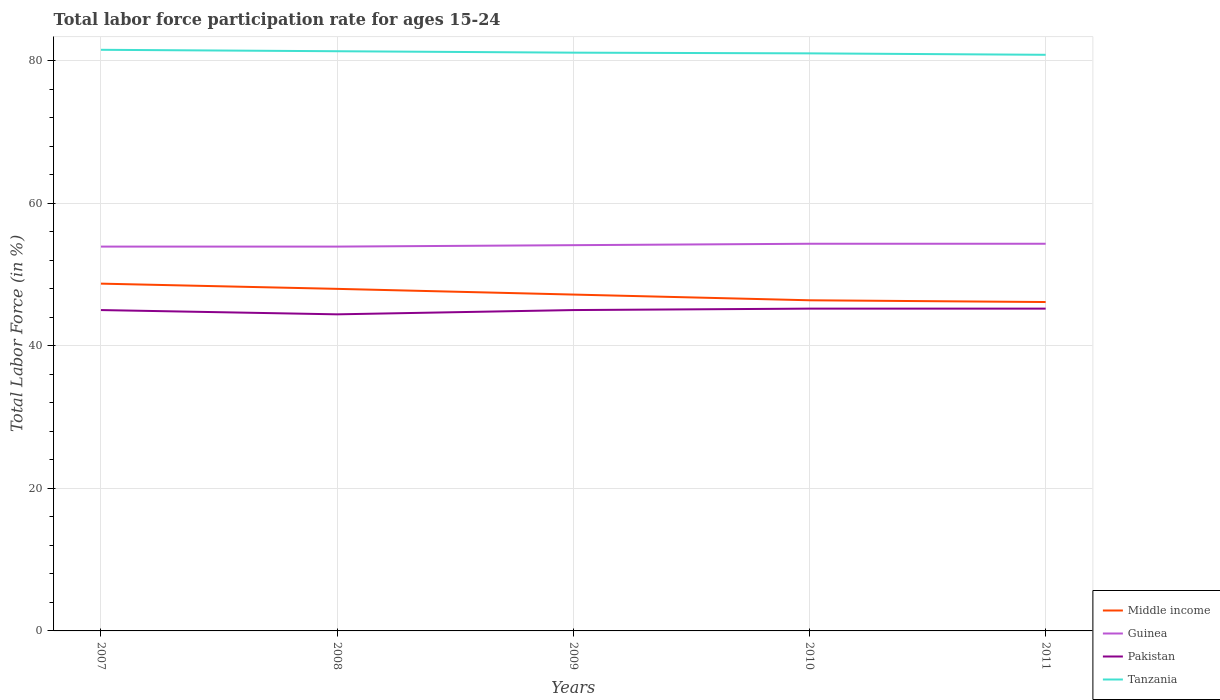How many different coloured lines are there?
Your answer should be compact. 4. Does the line corresponding to Guinea intersect with the line corresponding to Middle income?
Keep it short and to the point. No. Across all years, what is the maximum labor force participation rate in Guinea?
Give a very brief answer. 53.9. What is the difference between the highest and the second highest labor force participation rate in Guinea?
Offer a very short reply. 0.4. Is the labor force participation rate in Middle income strictly greater than the labor force participation rate in Tanzania over the years?
Your answer should be compact. Yes. How many years are there in the graph?
Keep it short and to the point. 5. What is the difference between two consecutive major ticks on the Y-axis?
Your answer should be very brief. 20. Does the graph contain grids?
Keep it short and to the point. Yes. Where does the legend appear in the graph?
Your response must be concise. Bottom right. What is the title of the graph?
Keep it short and to the point. Total labor force participation rate for ages 15-24. Does "Bosnia and Herzegovina" appear as one of the legend labels in the graph?
Make the answer very short. No. What is the Total Labor Force (in %) in Middle income in 2007?
Offer a very short reply. 48.7. What is the Total Labor Force (in %) in Guinea in 2007?
Make the answer very short. 53.9. What is the Total Labor Force (in %) in Tanzania in 2007?
Your answer should be very brief. 81.5. What is the Total Labor Force (in %) in Middle income in 2008?
Offer a very short reply. 47.97. What is the Total Labor Force (in %) in Guinea in 2008?
Give a very brief answer. 53.9. What is the Total Labor Force (in %) in Pakistan in 2008?
Offer a very short reply. 44.4. What is the Total Labor Force (in %) in Tanzania in 2008?
Offer a very short reply. 81.3. What is the Total Labor Force (in %) in Middle income in 2009?
Give a very brief answer. 47.17. What is the Total Labor Force (in %) of Guinea in 2009?
Keep it short and to the point. 54.1. What is the Total Labor Force (in %) in Pakistan in 2009?
Your answer should be very brief. 45. What is the Total Labor Force (in %) in Tanzania in 2009?
Offer a very short reply. 81.1. What is the Total Labor Force (in %) of Middle income in 2010?
Ensure brevity in your answer.  46.37. What is the Total Labor Force (in %) in Guinea in 2010?
Ensure brevity in your answer.  54.3. What is the Total Labor Force (in %) in Pakistan in 2010?
Provide a succinct answer. 45.2. What is the Total Labor Force (in %) in Tanzania in 2010?
Ensure brevity in your answer.  81. What is the Total Labor Force (in %) in Middle income in 2011?
Your response must be concise. 46.13. What is the Total Labor Force (in %) in Guinea in 2011?
Offer a terse response. 54.3. What is the Total Labor Force (in %) in Pakistan in 2011?
Your response must be concise. 45.2. What is the Total Labor Force (in %) of Tanzania in 2011?
Your answer should be very brief. 80.8. Across all years, what is the maximum Total Labor Force (in %) in Middle income?
Your response must be concise. 48.7. Across all years, what is the maximum Total Labor Force (in %) in Guinea?
Offer a very short reply. 54.3. Across all years, what is the maximum Total Labor Force (in %) in Pakistan?
Keep it short and to the point. 45.2. Across all years, what is the maximum Total Labor Force (in %) of Tanzania?
Provide a short and direct response. 81.5. Across all years, what is the minimum Total Labor Force (in %) of Middle income?
Offer a very short reply. 46.13. Across all years, what is the minimum Total Labor Force (in %) of Guinea?
Ensure brevity in your answer.  53.9. Across all years, what is the minimum Total Labor Force (in %) of Pakistan?
Offer a very short reply. 44.4. Across all years, what is the minimum Total Labor Force (in %) in Tanzania?
Your answer should be very brief. 80.8. What is the total Total Labor Force (in %) of Middle income in the graph?
Offer a very short reply. 236.35. What is the total Total Labor Force (in %) in Guinea in the graph?
Your answer should be very brief. 270.5. What is the total Total Labor Force (in %) of Pakistan in the graph?
Your answer should be very brief. 224.8. What is the total Total Labor Force (in %) of Tanzania in the graph?
Ensure brevity in your answer.  405.7. What is the difference between the Total Labor Force (in %) in Middle income in 2007 and that in 2008?
Your answer should be very brief. 0.73. What is the difference between the Total Labor Force (in %) in Guinea in 2007 and that in 2008?
Your response must be concise. 0. What is the difference between the Total Labor Force (in %) in Middle income in 2007 and that in 2009?
Give a very brief answer. 1.53. What is the difference between the Total Labor Force (in %) of Guinea in 2007 and that in 2009?
Provide a succinct answer. -0.2. What is the difference between the Total Labor Force (in %) in Tanzania in 2007 and that in 2009?
Make the answer very short. 0.4. What is the difference between the Total Labor Force (in %) of Middle income in 2007 and that in 2010?
Give a very brief answer. 2.33. What is the difference between the Total Labor Force (in %) of Pakistan in 2007 and that in 2010?
Ensure brevity in your answer.  -0.2. What is the difference between the Total Labor Force (in %) of Middle income in 2007 and that in 2011?
Keep it short and to the point. 2.58. What is the difference between the Total Labor Force (in %) in Guinea in 2007 and that in 2011?
Make the answer very short. -0.4. What is the difference between the Total Labor Force (in %) of Pakistan in 2007 and that in 2011?
Give a very brief answer. -0.2. What is the difference between the Total Labor Force (in %) in Middle income in 2008 and that in 2009?
Provide a succinct answer. 0.8. What is the difference between the Total Labor Force (in %) in Guinea in 2008 and that in 2009?
Provide a short and direct response. -0.2. What is the difference between the Total Labor Force (in %) of Middle income in 2008 and that in 2010?
Your answer should be very brief. 1.6. What is the difference between the Total Labor Force (in %) of Pakistan in 2008 and that in 2010?
Ensure brevity in your answer.  -0.8. What is the difference between the Total Labor Force (in %) in Middle income in 2008 and that in 2011?
Give a very brief answer. 1.85. What is the difference between the Total Labor Force (in %) in Guinea in 2008 and that in 2011?
Your answer should be compact. -0.4. What is the difference between the Total Labor Force (in %) of Middle income in 2009 and that in 2010?
Your answer should be very brief. 0.8. What is the difference between the Total Labor Force (in %) in Guinea in 2009 and that in 2010?
Provide a succinct answer. -0.2. What is the difference between the Total Labor Force (in %) of Middle income in 2009 and that in 2011?
Keep it short and to the point. 1.05. What is the difference between the Total Labor Force (in %) of Guinea in 2009 and that in 2011?
Keep it short and to the point. -0.2. What is the difference between the Total Labor Force (in %) of Middle income in 2010 and that in 2011?
Offer a terse response. 0.25. What is the difference between the Total Labor Force (in %) of Tanzania in 2010 and that in 2011?
Provide a succinct answer. 0.2. What is the difference between the Total Labor Force (in %) in Middle income in 2007 and the Total Labor Force (in %) in Guinea in 2008?
Your response must be concise. -5.2. What is the difference between the Total Labor Force (in %) in Middle income in 2007 and the Total Labor Force (in %) in Pakistan in 2008?
Offer a terse response. 4.3. What is the difference between the Total Labor Force (in %) of Middle income in 2007 and the Total Labor Force (in %) of Tanzania in 2008?
Your answer should be very brief. -32.6. What is the difference between the Total Labor Force (in %) in Guinea in 2007 and the Total Labor Force (in %) in Pakistan in 2008?
Your response must be concise. 9.5. What is the difference between the Total Labor Force (in %) of Guinea in 2007 and the Total Labor Force (in %) of Tanzania in 2008?
Your answer should be compact. -27.4. What is the difference between the Total Labor Force (in %) of Pakistan in 2007 and the Total Labor Force (in %) of Tanzania in 2008?
Give a very brief answer. -36.3. What is the difference between the Total Labor Force (in %) in Middle income in 2007 and the Total Labor Force (in %) in Guinea in 2009?
Ensure brevity in your answer.  -5.4. What is the difference between the Total Labor Force (in %) in Middle income in 2007 and the Total Labor Force (in %) in Pakistan in 2009?
Offer a terse response. 3.7. What is the difference between the Total Labor Force (in %) of Middle income in 2007 and the Total Labor Force (in %) of Tanzania in 2009?
Your response must be concise. -32.4. What is the difference between the Total Labor Force (in %) in Guinea in 2007 and the Total Labor Force (in %) in Tanzania in 2009?
Provide a short and direct response. -27.2. What is the difference between the Total Labor Force (in %) of Pakistan in 2007 and the Total Labor Force (in %) of Tanzania in 2009?
Offer a very short reply. -36.1. What is the difference between the Total Labor Force (in %) in Middle income in 2007 and the Total Labor Force (in %) in Guinea in 2010?
Your answer should be compact. -5.6. What is the difference between the Total Labor Force (in %) of Middle income in 2007 and the Total Labor Force (in %) of Pakistan in 2010?
Offer a very short reply. 3.5. What is the difference between the Total Labor Force (in %) of Middle income in 2007 and the Total Labor Force (in %) of Tanzania in 2010?
Provide a short and direct response. -32.3. What is the difference between the Total Labor Force (in %) in Guinea in 2007 and the Total Labor Force (in %) in Tanzania in 2010?
Keep it short and to the point. -27.1. What is the difference between the Total Labor Force (in %) of Pakistan in 2007 and the Total Labor Force (in %) of Tanzania in 2010?
Provide a succinct answer. -36. What is the difference between the Total Labor Force (in %) of Middle income in 2007 and the Total Labor Force (in %) of Guinea in 2011?
Offer a very short reply. -5.6. What is the difference between the Total Labor Force (in %) of Middle income in 2007 and the Total Labor Force (in %) of Pakistan in 2011?
Offer a terse response. 3.5. What is the difference between the Total Labor Force (in %) in Middle income in 2007 and the Total Labor Force (in %) in Tanzania in 2011?
Make the answer very short. -32.1. What is the difference between the Total Labor Force (in %) in Guinea in 2007 and the Total Labor Force (in %) in Tanzania in 2011?
Provide a succinct answer. -26.9. What is the difference between the Total Labor Force (in %) in Pakistan in 2007 and the Total Labor Force (in %) in Tanzania in 2011?
Offer a very short reply. -35.8. What is the difference between the Total Labor Force (in %) in Middle income in 2008 and the Total Labor Force (in %) in Guinea in 2009?
Keep it short and to the point. -6.13. What is the difference between the Total Labor Force (in %) in Middle income in 2008 and the Total Labor Force (in %) in Pakistan in 2009?
Offer a terse response. 2.97. What is the difference between the Total Labor Force (in %) in Middle income in 2008 and the Total Labor Force (in %) in Tanzania in 2009?
Your response must be concise. -33.13. What is the difference between the Total Labor Force (in %) in Guinea in 2008 and the Total Labor Force (in %) in Tanzania in 2009?
Keep it short and to the point. -27.2. What is the difference between the Total Labor Force (in %) of Pakistan in 2008 and the Total Labor Force (in %) of Tanzania in 2009?
Provide a succinct answer. -36.7. What is the difference between the Total Labor Force (in %) in Middle income in 2008 and the Total Labor Force (in %) in Guinea in 2010?
Provide a short and direct response. -6.33. What is the difference between the Total Labor Force (in %) in Middle income in 2008 and the Total Labor Force (in %) in Pakistan in 2010?
Provide a short and direct response. 2.77. What is the difference between the Total Labor Force (in %) in Middle income in 2008 and the Total Labor Force (in %) in Tanzania in 2010?
Provide a succinct answer. -33.03. What is the difference between the Total Labor Force (in %) in Guinea in 2008 and the Total Labor Force (in %) in Pakistan in 2010?
Make the answer very short. 8.7. What is the difference between the Total Labor Force (in %) in Guinea in 2008 and the Total Labor Force (in %) in Tanzania in 2010?
Ensure brevity in your answer.  -27.1. What is the difference between the Total Labor Force (in %) of Pakistan in 2008 and the Total Labor Force (in %) of Tanzania in 2010?
Keep it short and to the point. -36.6. What is the difference between the Total Labor Force (in %) of Middle income in 2008 and the Total Labor Force (in %) of Guinea in 2011?
Offer a very short reply. -6.33. What is the difference between the Total Labor Force (in %) in Middle income in 2008 and the Total Labor Force (in %) in Pakistan in 2011?
Your response must be concise. 2.77. What is the difference between the Total Labor Force (in %) in Middle income in 2008 and the Total Labor Force (in %) in Tanzania in 2011?
Offer a very short reply. -32.83. What is the difference between the Total Labor Force (in %) of Guinea in 2008 and the Total Labor Force (in %) of Tanzania in 2011?
Offer a very short reply. -26.9. What is the difference between the Total Labor Force (in %) in Pakistan in 2008 and the Total Labor Force (in %) in Tanzania in 2011?
Give a very brief answer. -36.4. What is the difference between the Total Labor Force (in %) in Middle income in 2009 and the Total Labor Force (in %) in Guinea in 2010?
Your answer should be compact. -7.13. What is the difference between the Total Labor Force (in %) of Middle income in 2009 and the Total Labor Force (in %) of Pakistan in 2010?
Provide a short and direct response. 1.97. What is the difference between the Total Labor Force (in %) of Middle income in 2009 and the Total Labor Force (in %) of Tanzania in 2010?
Ensure brevity in your answer.  -33.83. What is the difference between the Total Labor Force (in %) in Guinea in 2009 and the Total Labor Force (in %) in Tanzania in 2010?
Give a very brief answer. -26.9. What is the difference between the Total Labor Force (in %) of Pakistan in 2009 and the Total Labor Force (in %) of Tanzania in 2010?
Keep it short and to the point. -36. What is the difference between the Total Labor Force (in %) in Middle income in 2009 and the Total Labor Force (in %) in Guinea in 2011?
Your answer should be very brief. -7.13. What is the difference between the Total Labor Force (in %) in Middle income in 2009 and the Total Labor Force (in %) in Pakistan in 2011?
Provide a short and direct response. 1.97. What is the difference between the Total Labor Force (in %) of Middle income in 2009 and the Total Labor Force (in %) of Tanzania in 2011?
Your answer should be very brief. -33.63. What is the difference between the Total Labor Force (in %) of Guinea in 2009 and the Total Labor Force (in %) of Tanzania in 2011?
Provide a short and direct response. -26.7. What is the difference between the Total Labor Force (in %) in Pakistan in 2009 and the Total Labor Force (in %) in Tanzania in 2011?
Your answer should be compact. -35.8. What is the difference between the Total Labor Force (in %) in Middle income in 2010 and the Total Labor Force (in %) in Guinea in 2011?
Your answer should be very brief. -7.93. What is the difference between the Total Labor Force (in %) in Middle income in 2010 and the Total Labor Force (in %) in Pakistan in 2011?
Your response must be concise. 1.17. What is the difference between the Total Labor Force (in %) in Middle income in 2010 and the Total Labor Force (in %) in Tanzania in 2011?
Provide a succinct answer. -34.43. What is the difference between the Total Labor Force (in %) in Guinea in 2010 and the Total Labor Force (in %) in Pakistan in 2011?
Your response must be concise. 9.1. What is the difference between the Total Labor Force (in %) in Guinea in 2010 and the Total Labor Force (in %) in Tanzania in 2011?
Give a very brief answer. -26.5. What is the difference between the Total Labor Force (in %) in Pakistan in 2010 and the Total Labor Force (in %) in Tanzania in 2011?
Make the answer very short. -35.6. What is the average Total Labor Force (in %) of Middle income per year?
Make the answer very short. 47.27. What is the average Total Labor Force (in %) of Guinea per year?
Give a very brief answer. 54.1. What is the average Total Labor Force (in %) in Pakistan per year?
Provide a short and direct response. 44.96. What is the average Total Labor Force (in %) in Tanzania per year?
Your answer should be very brief. 81.14. In the year 2007, what is the difference between the Total Labor Force (in %) of Middle income and Total Labor Force (in %) of Guinea?
Keep it short and to the point. -5.2. In the year 2007, what is the difference between the Total Labor Force (in %) of Middle income and Total Labor Force (in %) of Pakistan?
Your answer should be compact. 3.7. In the year 2007, what is the difference between the Total Labor Force (in %) in Middle income and Total Labor Force (in %) in Tanzania?
Offer a terse response. -32.8. In the year 2007, what is the difference between the Total Labor Force (in %) of Guinea and Total Labor Force (in %) of Pakistan?
Make the answer very short. 8.9. In the year 2007, what is the difference between the Total Labor Force (in %) of Guinea and Total Labor Force (in %) of Tanzania?
Provide a succinct answer. -27.6. In the year 2007, what is the difference between the Total Labor Force (in %) in Pakistan and Total Labor Force (in %) in Tanzania?
Ensure brevity in your answer.  -36.5. In the year 2008, what is the difference between the Total Labor Force (in %) in Middle income and Total Labor Force (in %) in Guinea?
Ensure brevity in your answer.  -5.93. In the year 2008, what is the difference between the Total Labor Force (in %) of Middle income and Total Labor Force (in %) of Pakistan?
Make the answer very short. 3.57. In the year 2008, what is the difference between the Total Labor Force (in %) in Middle income and Total Labor Force (in %) in Tanzania?
Your answer should be very brief. -33.33. In the year 2008, what is the difference between the Total Labor Force (in %) of Guinea and Total Labor Force (in %) of Pakistan?
Give a very brief answer. 9.5. In the year 2008, what is the difference between the Total Labor Force (in %) in Guinea and Total Labor Force (in %) in Tanzania?
Keep it short and to the point. -27.4. In the year 2008, what is the difference between the Total Labor Force (in %) in Pakistan and Total Labor Force (in %) in Tanzania?
Offer a terse response. -36.9. In the year 2009, what is the difference between the Total Labor Force (in %) of Middle income and Total Labor Force (in %) of Guinea?
Give a very brief answer. -6.93. In the year 2009, what is the difference between the Total Labor Force (in %) of Middle income and Total Labor Force (in %) of Pakistan?
Keep it short and to the point. 2.17. In the year 2009, what is the difference between the Total Labor Force (in %) of Middle income and Total Labor Force (in %) of Tanzania?
Keep it short and to the point. -33.93. In the year 2009, what is the difference between the Total Labor Force (in %) in Guinea and Total Labor Force (in %) in Pakistan?
Your answer should be very brief. 9.1. In the year 2009, what is the difference between the Total Labor Force (in %) in Guinea and Total Labor Force (in %) in Tanzania?
Your answer should be compact. -27. In the year 2009, what is the difference between the Total Labor Force (in %) of Pakistan and Total Labor Force (in %) of Tanzania?
Provide a succinct answer. -36.1. In the year 2010, what is the difference between the Total Labor Force (in %) of Middle income and Total Labor Force (in %) of Guinea?
Your answer should be compact. -7.93. In the year 2010, what is the difference between the Total Labor Force (in %) of Middle income and Total Labor Force (in %) of Pakistan?
Make the answer very short. 1.17. In the year 2010, what is the difference between the Total Labor Force (in %) in Middle income and Total Labor Force (in %) in Tanzania?
Ensure brevity in your answer.  -34.63. In the year 2010, what is the difference between the Total Labor Force (in %) of Guinea and Total Labor Force (in %) of Pakistan?
Your answer should be very brief. 9.1. In the year 2010, what is the difference between the Total Labor Force (in %) of Guinea and Total Labor Force (in %) of Tanzania?
Provide a short and direct response. -26.7. In the year 2010, what is the difference between the Total Labor Force (in %) of Pakistan and Total Labor Force (in %) of Tanzania?
Your answer should be compact. -35.8. In the year 2011, what is the difference between the Total Labor Force (in %) of Middle income and Total Labor Force (in %) of Guinea?
Give a very brief answer. -8.17. In the year 2011, what is the difference between the Total Labor Force (in %) of Middle income and Total Labor Force (in %) of Pakistan?
Your answer should be very brief. 0.93. In the year 2011, what is the difference between the Total Labor Force (in %) in Middle income and Total Labor Force (in %) in Tanzania?
Provide a succinct answer. -34.67. In the year 2011, what is the difference between the Total Labor Force (in %) of Guinea and Total Labor Force (in %) of Tanzania?
Offer a very short reply. -26.5. In the year 2011, what is the difference between the Total Labor Force (in %) in Pakistan and Total Labor Force (in %) in Tanzania?
Provide a succinct answer. -35.6. What is the ratio of the Total Labor Force (in %) of Middle income in 2007 to that in 2008?
Give a very brief answer. 1.02. What is the ratio of the Total Labor Force (in %) of Guinea in 2007 to that in 2008?
Provide a short and direct response. 1. What is the ratio of the Total Labor Force (in %) of Pakistan in 2007 to that in 2008?
Keep it short and to the point. 1.01. What is the ratio of the Total Labor Force (in %) of Tanzania in 2007 to that in 2008?
Provide a short and direct response. 1. What is the ratio of the Total Labor Force (in %) of Middle income in 2007 to that in 2009?
Provide a succinct answer. 1.03. What is the ratio of the Total Labor Force (in %) of Guinea in 2007 to that in 2009?
Provide a short and direct response. 1. What is the ratio of the Total Labor Force (in %) of Tanzania in 2007 to that in 2009?
Provide a short and direct response. 1. What is the ratio of the Total Labor Force (in %) of Middle income in 2007 to that in 2010?
Your answer should be compact. 1.05. What is the ratio of the Total Labor Force (in %) of Guinea in 2007 to that in 2010?
Provide a short and direct response. 0.99. What is the ratio of the Total Labor Force (in %) in Tanzania in 2007 to that in 2010?
Your answer should be compact. 1.01. What is the ratio of the Total Labor Force (in %) in Middle income in 2007 to that in 2011?
Keep it short and to the point. 1.06. What is the ratio of the Total Labor Force (in %) in Pakistan in 2007 to that in 2011?
Ensure brevity in your answer.  1. What is the ratio of the Total Labor Force (in %) of Tanzania in 2007 to that in 2011?
Provide a short and direct response. 1.01. What is the ratio of the Total Labor Force (in %) of Middle income in 2008 to that in 2009?
Your response must be concise. 1.02. What is the ratio of the Total Labor Force (in %) of Pakistan in 2008 to that in 2009?
Provide a short and direct response. 0.99. What is the ratio of the Total Labor Force (in %) of Middle income in 2008 to that in 2010?
Your answer should be very brief. 1.03. What is the ratio of the Total Labor Force (in %) in Pakistan in 2008 to that in 2010?
Keep it short and to the point. 0.98. What is the ratio of the Total Labor Force (in %) in Tanzania in 2008 to that in 2010?
Keep it short and to the point. 1. What is the ratio of the Total Labor Force (in %) of Middle income in 2008 to that in 2011?
Give a very brief answer. 1.04. What is the ratio of the Total Labor Force (in %) in Guinea in 2008 to that in 2011?
Your response must be concise. 0.99. What is the ratio of the Total Labor Force (in %) in Pakistan in 2008 to that in 2011?
Offer a terse response. 0.98. What is the ratio of the Total Labor Force (in %) in Tanzania in 2008 to that in 2011?
Your answer should be very brief. 1.01. What is the ratio of the Total Labor Force (in %) in Middle income in 2009 to that in 2010?
Provide a succinct answer. 1.02. What is the ratio of the Total Labor Force (in %) in Pakistan in 2009 to that in 2010?
Your answer should be compact. 1. What is the ratio of the Total Labor Force (in %) in Tanzania in 2009 to that in 2010?
Your answer should be compact. 1. What is the ratio of the Total Labor Force (in %) of Middle income in 2009 to that in 2011?
Keep it short and to the point. 1.02. What is the ratio of the Total Labor Force (in %) in Pakistan in 2009 to that in 2011?
Give a very brief answer. 1. What is the ratio of the Total Labor Force (in %) in Tanzania in 2009 to that in 2011?
Give a very brief answer. 1. What is the ratio of the Total Labor Force (in %) in Middle income in 2010 to that in 2011?
Keep it short and to the point. 1.01. What is the ratio of the Total Labor Force (in %) in Guinea in 2010 to that in 2011?
Keep it short and to the point. 1. What is the ratio of the Total Labor Force (in %) of Pakistan in 2010 to that in 2011?
Give a very brief answer. 1. What is the ratio of the Total Labor Force (in %) in Tanzania in 2010 to that in 2011?
Your response must be concise. 1. What is the difference between the highest and the second highest Total Labor Force (in %) of Middle income?
Your response must be concise. 0.73. What is the difference between the highest and the second highest Total Labor Force (in %) in Guinea?
Your answer should be compact. 0. What is the difference between the highest and the lowest Total Labor Force (in %) of Middle income?
Provide a succinct answer. 2.58. What is the difference between the highest and the lowest Total Labor Force (in %) of Guinea?
Your answer should be very brief. 0.4. What is the difference between the highest and the lowest Total Labor Force (in %) of Tanzania?
Make the answer very short. 0.7. 